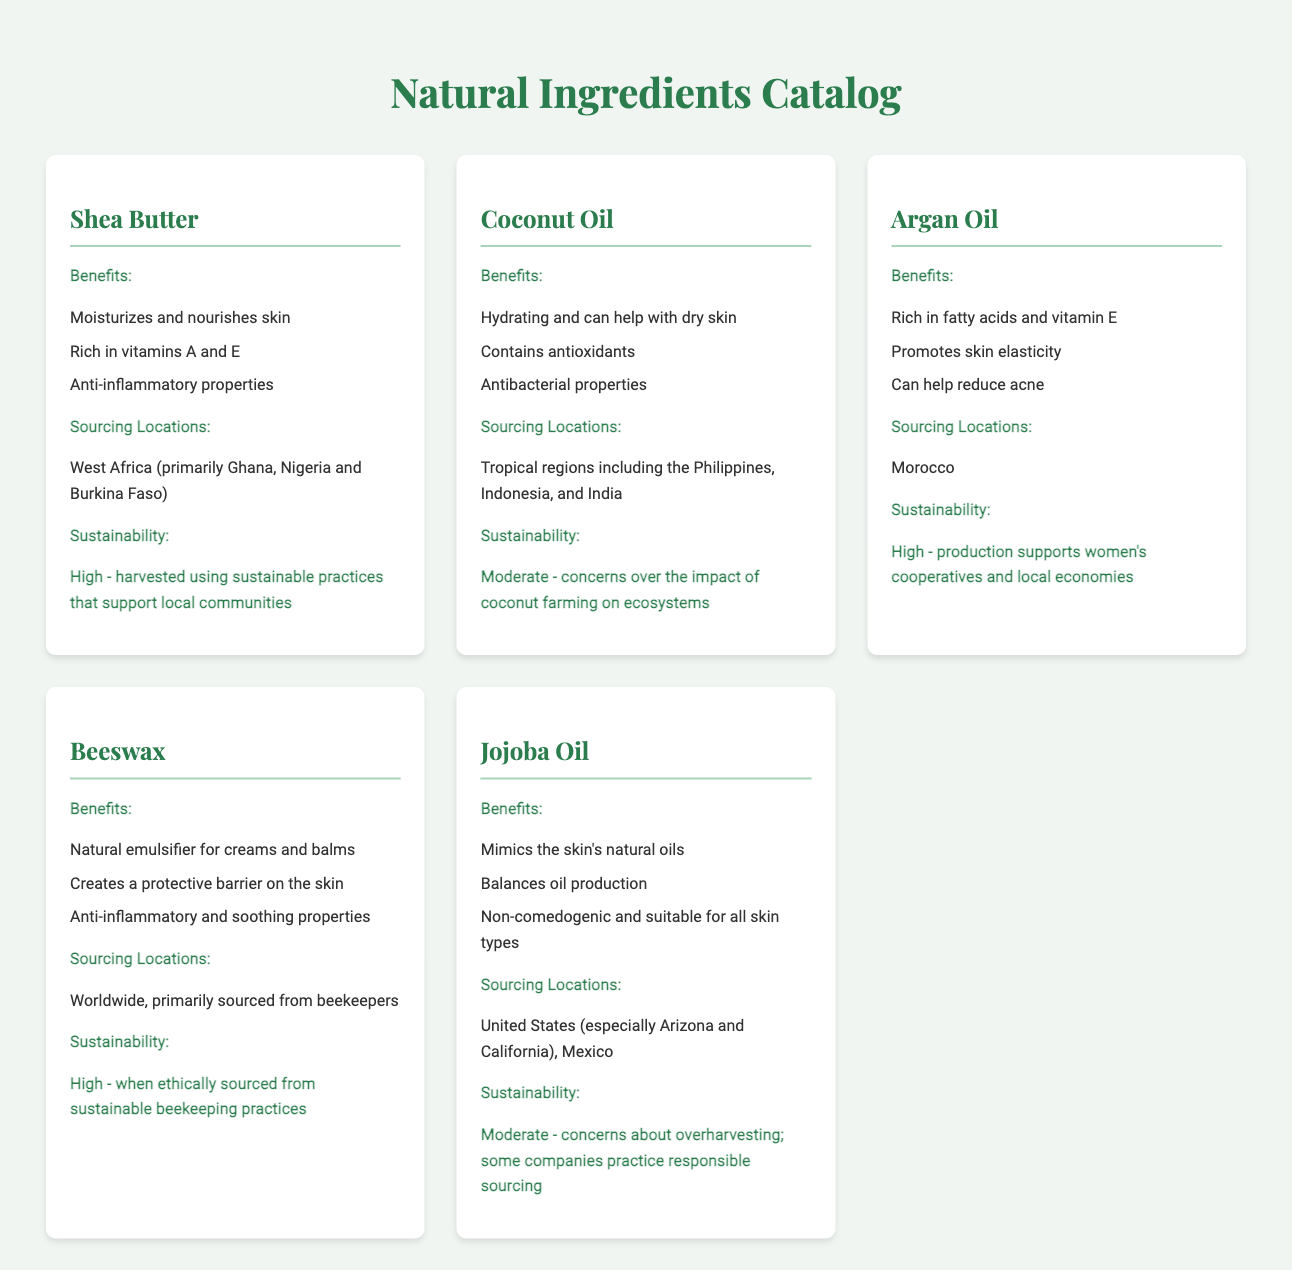What are the benefits of Shea Butter? The benefits of Shea Butter include moisturizing and nourishing skin, being rich in vitamins A and E, and having anti-inflammatory properties.
Answer: Moisturizes and nourishes skin, rich in vitamins A and E, anti-inflammatory properties Which ingredient is sourced from Morocco? The ingredient sourced from Morocco is Argan Oil, as mentioned in the sourcing locations section.
Answer: Argan Oil What is the sustainability rating of Beeswax? The sustainability rating of Beeswax is high when ethically sourced from sustainable beekeeping practices.
Answer: High What are the sourcing locations for Coconut Oil? The sourcing locations for Coconut Oil include tropical regions such as the Philippines, Indonesia, and India.
Answer: Tropical regions including the Philippines, Indonesia, and India How does Jojoba Oil affect oil production in the skin? Jojoba Oil balances oil production, helping to regulate the natural oils in the skin.
Answer: Balances oil production Which ingredient promotes skin elasticity? Argan Oil promotes skin elasticity as stated in the benefits section.
Answer: Argan Oil What property does Beeswax provide to creams and balms? Beeswax acts as a natural emulsifier for creams and balms according to the benefits listed.
Answer: Natural emulsifier Where is Shea Butter primarily sourced from? Shea Butter is primarily sourced from West Africa, specifically countries like Ghana, Nigeria, and Burkina Faso.
Answer: West Africa (primarily Ghana, Nigeria and Burkina Faso) What is a major concern related to the sustainability of Jojoba Oil? A major concern related to the sustainability of Jojoba Oil is overharvesting, although some companies practice responsible sourcing.
Answer: Overharvesting 